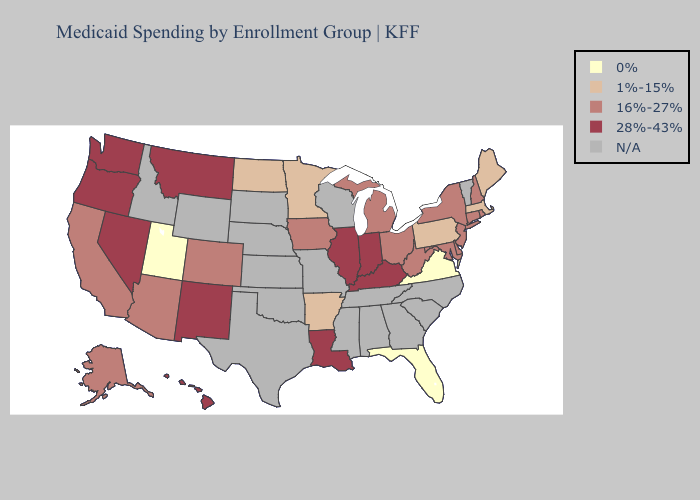What is the lowest value in states that border Minnesota?
Answer briefly. 1%-15%. Which states have the lowest value in the Northeast?
Concise answer only. Maine, Massachusetts, Pennsylvania. Does Virginia have the lowest value in the USA?
Concise answer only. Yes. Among the states that border Indiana , does Michigan have the highest value?
Short answer required. No. What is the value of Nebraska?
Answer briefly. N/A. What is the lowest value in the USA?
Write a very short answer. 0%. Name the states that have a value in the range N/A?
Be succinct. Alabama, Georgia, Idaho, Kansas, Mississippi, Missouri, Nebraska, North Carolina, Oklahoma, South Carolina, South Dakota, Tennessee, Texas, Vermont, Wisconsin, Wyoming. Among the states that border Virginia , which have the highest value?
Short answer required. Kentucky. What is the value of Wisconsin?
Give a very brief answer. N/A. What is the value of Montana?
Keep it brief. 28%-43%. Is the legend a continuous bar?
Concise answer only. No. Does the first symbol in the legend represent the smallest category?
Give a very brief answer. Yes. Which states hav the highest value in the Northeast?
Be succinct. Connecticut, New Hampshire, New Jersey, New York, Rhode Island. Which states have the lowest value in the West?
Keep it brief. Utah. What is the lowest value in the USA?
Keep it brief. 0%. 